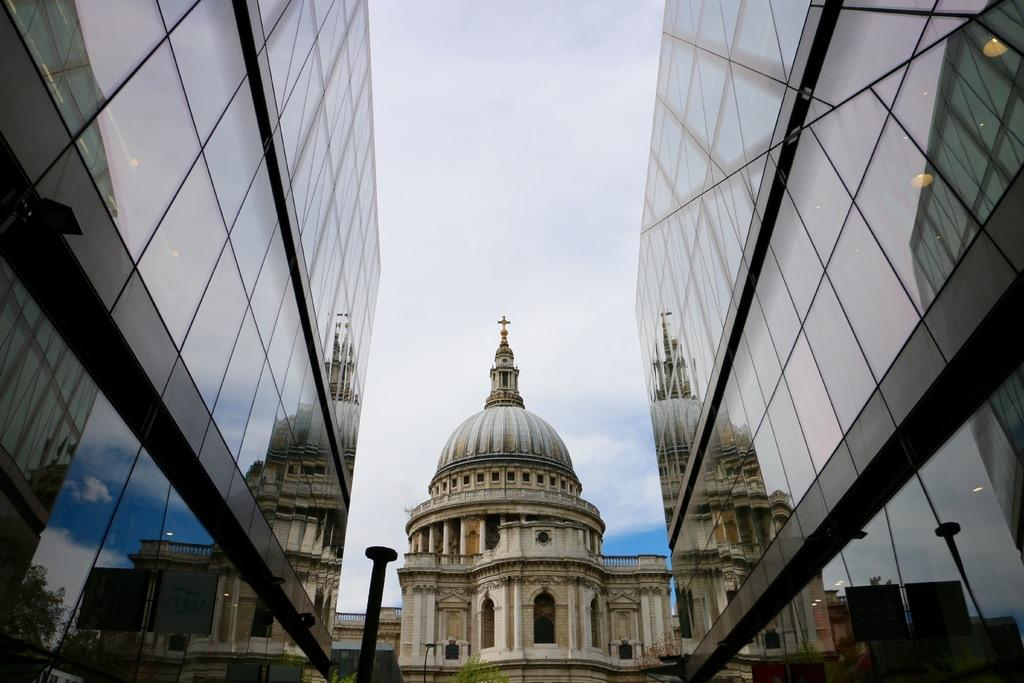What structures can be seen on the right side of the image? There are buildings on the right side of the image. What structures can be seen on the left side of the image? There are buildings on the left side of the image. What type of building is located in the center of the image? There appears to be a church in the center of the image. What type of architectural feature is visible in the image? There is railing visible in the image. What other object can be seen in the image? There is a pole in the image. What is visible at the top of the image? The sky is visible at the top of the image. Can you tell me how many frames are present in the image? There are no frames present in the image; it is a photograph or digital image. What type of tramp is visible in the image? There is no tramp present in the image. 